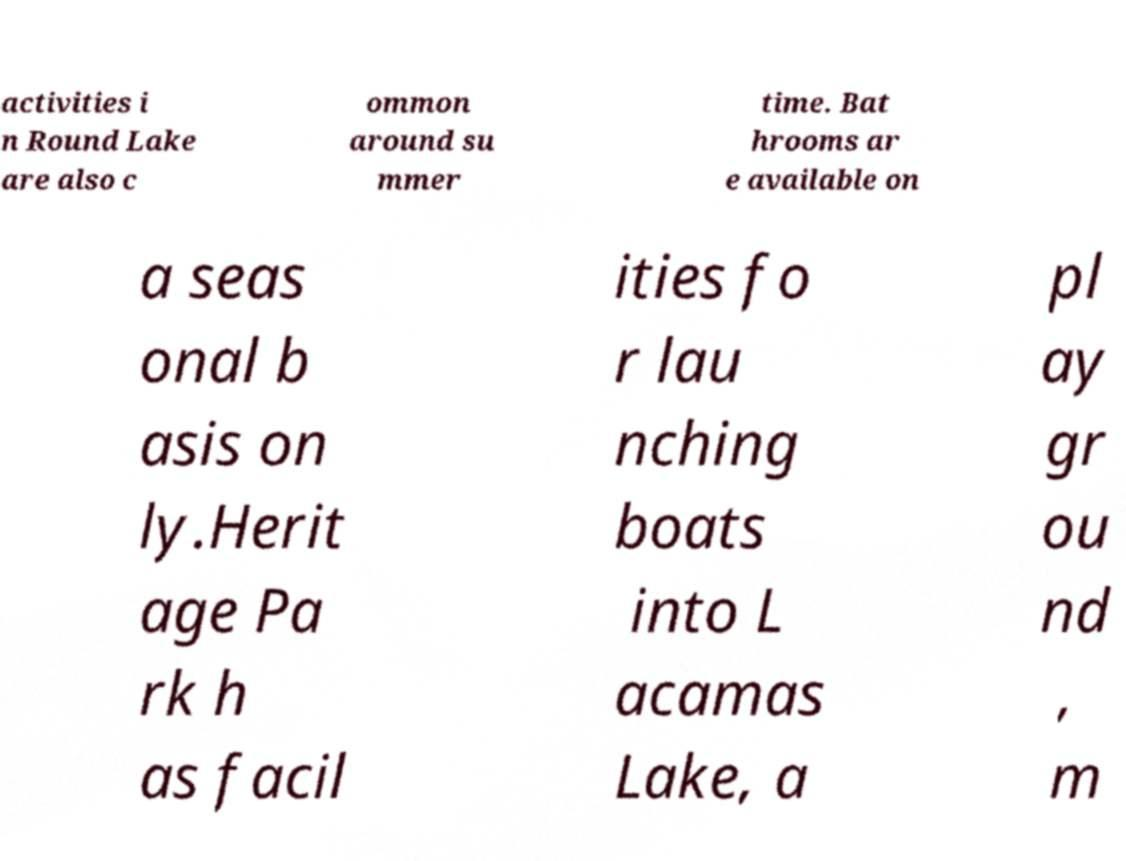Please read and relay the text visible in this image. What does it say? activities i n Round Lake are also c ommon around su mmer time. Bat hrooms ar e available on a seas onal b asis on ly.Herit age Pa rk h as facil ities fo r lau nching boats into L acamas Lake, a pl ay gr ou nd , m 